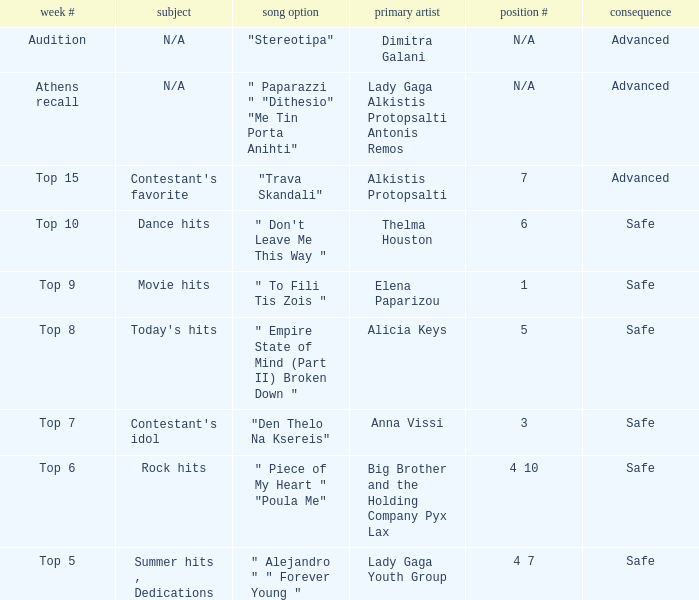Could you parse the entire table? {'header': ['week #', 'subject', 'song option', 'primary artist', 'position #', 'consequence'], 'rows': [['Audition', 'N/A', '"Stereotipa"', 'Dimitra Galani', 'N/A', 'Advanced'], ['Athens recall', 'N/A', '" Paparazzi " "Dithesio" "Me Tin Porta Anihti"', 'Lady Gaga Alkistis Protopsalti Antonis Remos', 'N/A', 'Advanced'], ['Top 15', "Contestant's favorite", '"Trava Skandali"', 'Alkistis Protopsalti', '7', 'Advanced'], ['Top 10', 'Dance hits', '" Don\'t Leave Me This Way "', 'Thelma Houston', '6', 'Safe'], ['Top 9', 'Movie hits', '" To Fili Tis Zois "', 'Elena Paparizou', '1', 'Safe'], ['Top 8', "Today's hits", '" Empire State of Mind (Part II) Broken Down "', 'Alicia Keys', '5', 'Safe'], ['Top 7', "Contestant's idol", '"Den Thelo Na Ksereis"', 'Anna Vissi', '3', 'Safe'], ['Top 6', 'Rock hits', '" Piece of My Heart " "Poula Me"', 'Big Brother and the Holding Company Pyx Lax', '4 10', 'Safe'], ['Top 5', 'Summer hits , Dedications', '" Alejandro " " Forever Young "', 'Lady Gaga Youth Group', '4 7', 'Safe']]} Which tune was picked during the audition week? "Stereotipa". 